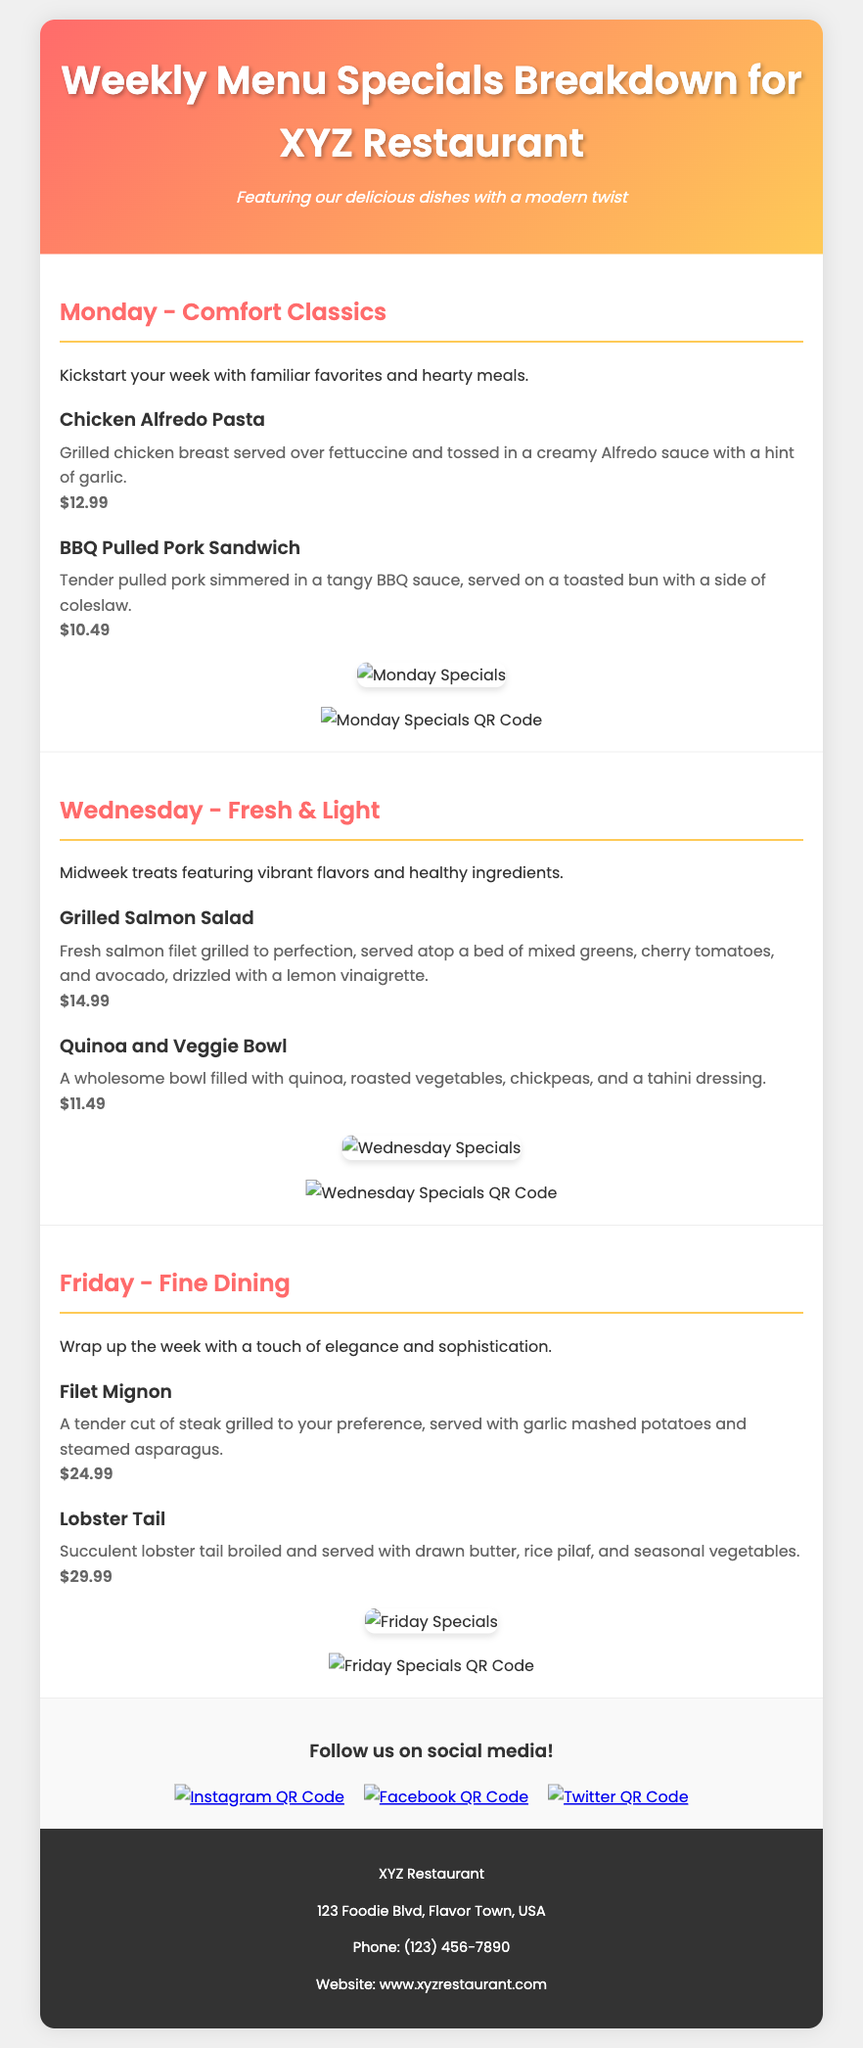What is the price of Chicken Alfredo Pasta? The price for Chicken Alfredo Pasta is listed in the document under Monday specials.
Answer: $12.99 What day features Fresh & Light menu items? The document specifies that Fresh & Light items are featured on Wednesday.
Answer: Wednesday How much does the Lobster Tail cost? The Lobster Tail price can be found in the Friday section of the document.
Answer: $29.99 Which dish is served on Monday that includes pulled pork? The document mentions BBQ Pulled Pork Sandwich under Monday specials.
Answer: BBQ Pulled Pork Sandwich What type of salad is featured on Wednesday? The document describes a Grilled Salmon Salad in the Wednesday section.
Answer: Grilled Salmon Salad What is the total number of specials listed for the week? The document outlines specials for three days, which indicates the total number of specials.
Answer: 3 What color theme is used in the header? The document states that the header features a gradient combining pink and yellow colors.
Answer: Pink and yellow What type of dessert might a guest expect if they visit on Friday? By reasoning from the fine dining theme on Friday, guests can expect an elegant dessert selection, though none is specified.
Answer: Elegant dessert selection Which social media platforms can you access through QR codes? The document lists Instagram, Facebook, and Twitter as the platforms with QR code links.
Answer: Instagram, Facebook, Twitter 